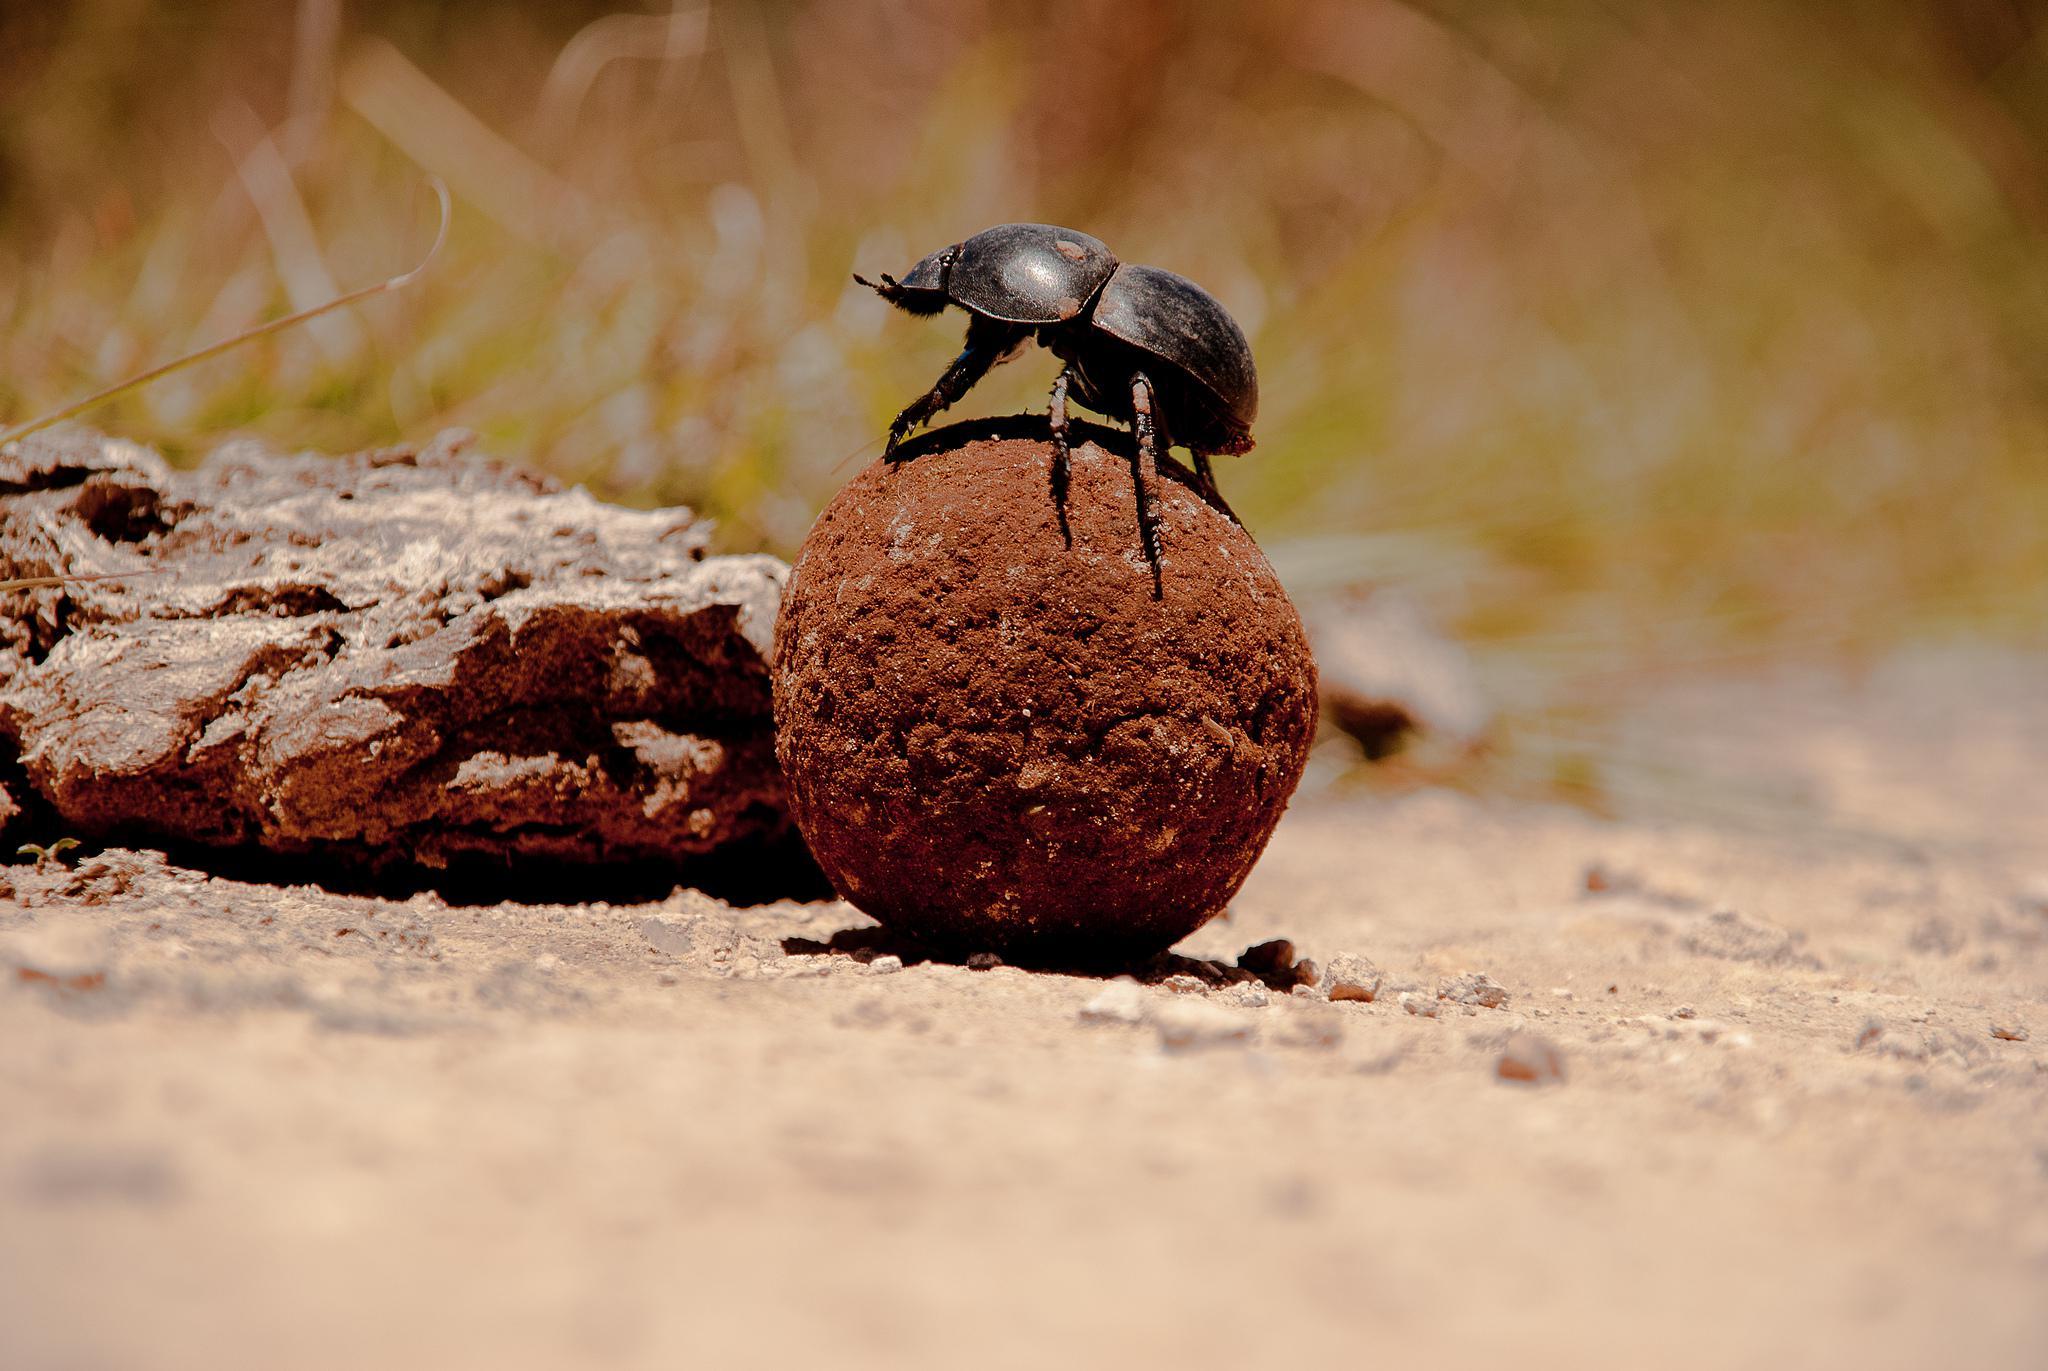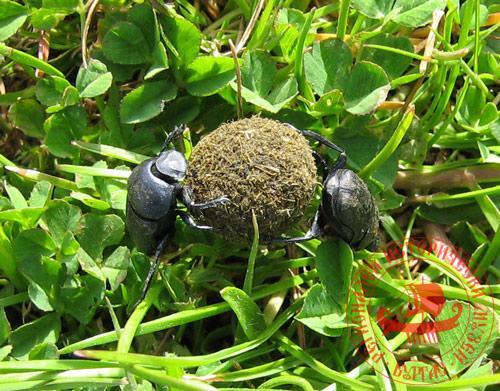The first image is the image on the left, the second image is the image on the right. Considering the images on both sides, is "There are exactly three dung beetles." valid? Answer yes or no. Yes. The first image is the image on the left, the second image is the image on the right. For the images shown, is this caption "there is one beetle with dung in the left side image" true? Answer yes or no. Yes. 